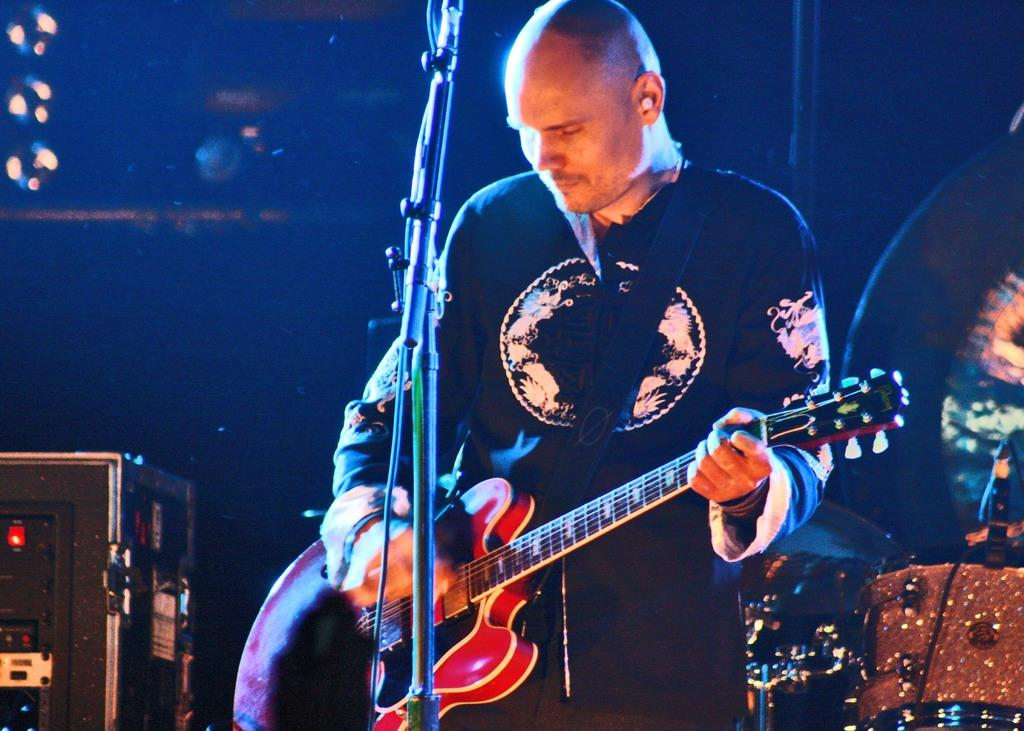What is the person in the image doing? The person is playing a guitar. What is the person wearing in the image? The person is wearing a black T-shirt. What object is in front of the person? There is a microphone in front of the person. What can be seen on the left side of the image? There is a box on the left side of the image. What type of scissors can be seen on the floor in the image? There are no scissors present in the image, and the floor is not visible. 